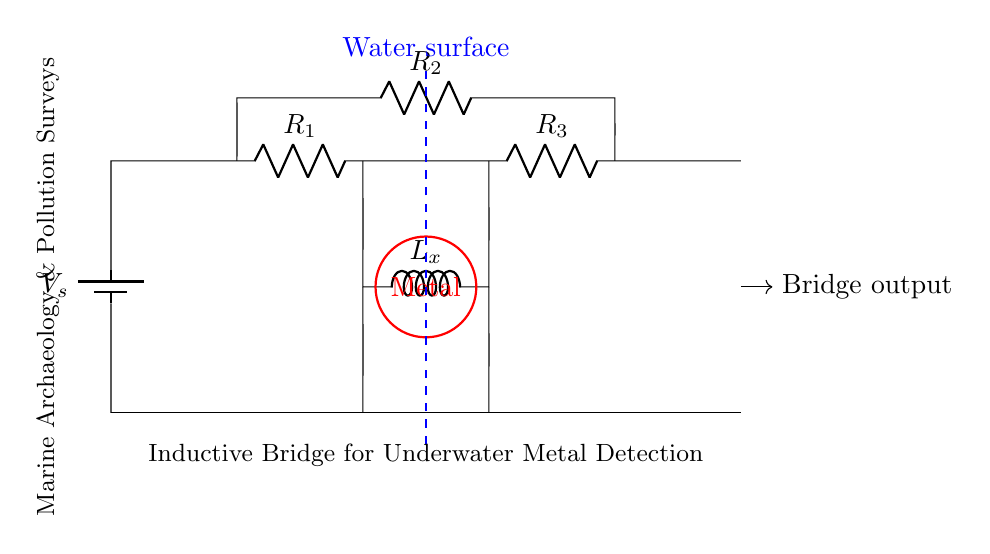What type of circuit is this? This circuit is an inductive bridge circuit because it utilizes inductors and resistors in a balanced configuration. The inclusion of inductors allows it to detect changes in inductance, which can indicate the presence of metal underwater.
Answer: Inductive bridge What is the purpose of this circuit? The purpose of this circuit is to detect underwater metal, particularly for applications in marine archaeology and pollution surveys. This is indicated by the labels and the design of the circuit that focuses on inductive changes due to metal presence.
Answer: Metal detection How many resistors are in the circuit? There are three resistors in the circuit, labeled R1, R2, and R3. It is evident from the diagram where the resistor symbols are present, totaling three distinct resistive components.
Answer: Three What component represents the underwater metal? The red circle represents the underwater metal in the circuit, indicated by the label “Metal.” This visual representation highlights where the metal influences the inductive balance of the circuit.
Answer: Metal What does the dashed blue line represent? The dashed blue line represents the water surface, as labeled in the diagram. It provides a visual cue about where the circuit's operation occurs, indicating it is designed for underwater use.
Answer: Water surface Why is a balance necessary in this bridge circuit? A balance is necessary in this bridge circuit because it enables accurate detection of inductive changes when metal is introduced into the field. If the circuit is unbalanced, it indicates the presence of metal as it alters the inductive properties measured by the circuit.
Answer: Accurate detection 